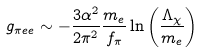Convert formula to latex. <formula><loc_0><loc_0><loc_500><loc_500>g _ { \pi e e } \sim - \frac { 3 { \alpha } ^ { 2 } } { 2 { \pi } ^ { 2 } } \frac { m _ { e } } { f _ { \pi } } \ln \left ( \frac { \Lambda _ { \chi } } { m _ { e } } \right )</formula> 